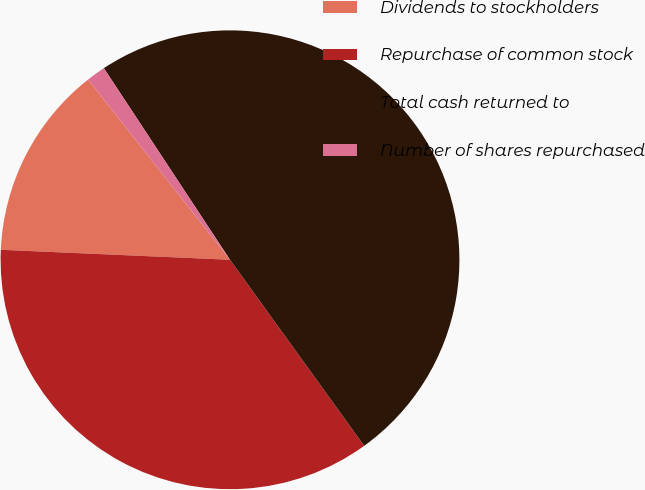Convert chart to OTSL. <chart><loc_0><loc_0><loc_500><loc_500><pie_chart><fcel>Dividends to stockholders<fcel>Repurchase of common stock<fcel>Total cash returned to<fcel>Number of shares repurchased<nl><fcel>13.69%<fcel>35.64%<fcel>49.32%<fcel>1.35%<nl></chart> 